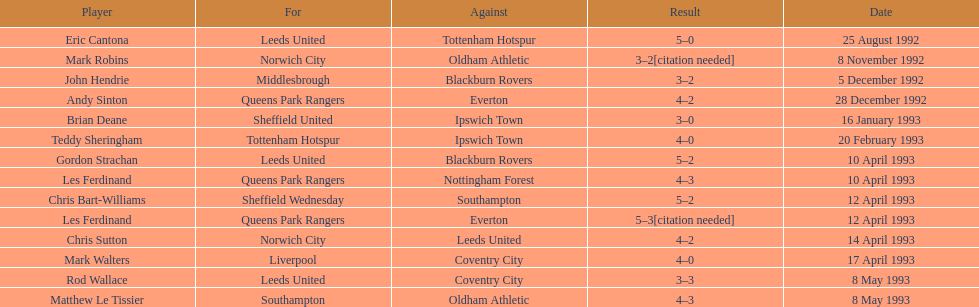Name the only player from france. Eric Cantona. 